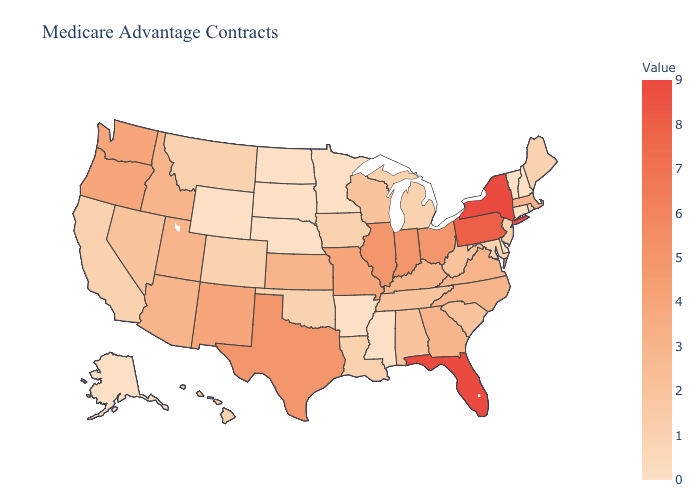Which states hav the highest value in the West?
Write a very short answer. New Mexico, Oregon, Washington. Does North Dakota have the highest value in the USA?
Concise answer only. No. Which states have the lowest value in the West?
Give a very brief answer. Alaska, Wyoming. Does North Dakota have the highest value in the MidWest?
Quick response, please. No. Does the map have missing data?
Write a very short answer. No. Which states have the lowest value in the USA?
Give a very brief answer. Alaska, Arkansas, Connecticut, Delaware, Minnesota, Mississippi, North Dakota, Nebraska, New Hampshire, South Dakota, Vermont, Wyoming. 